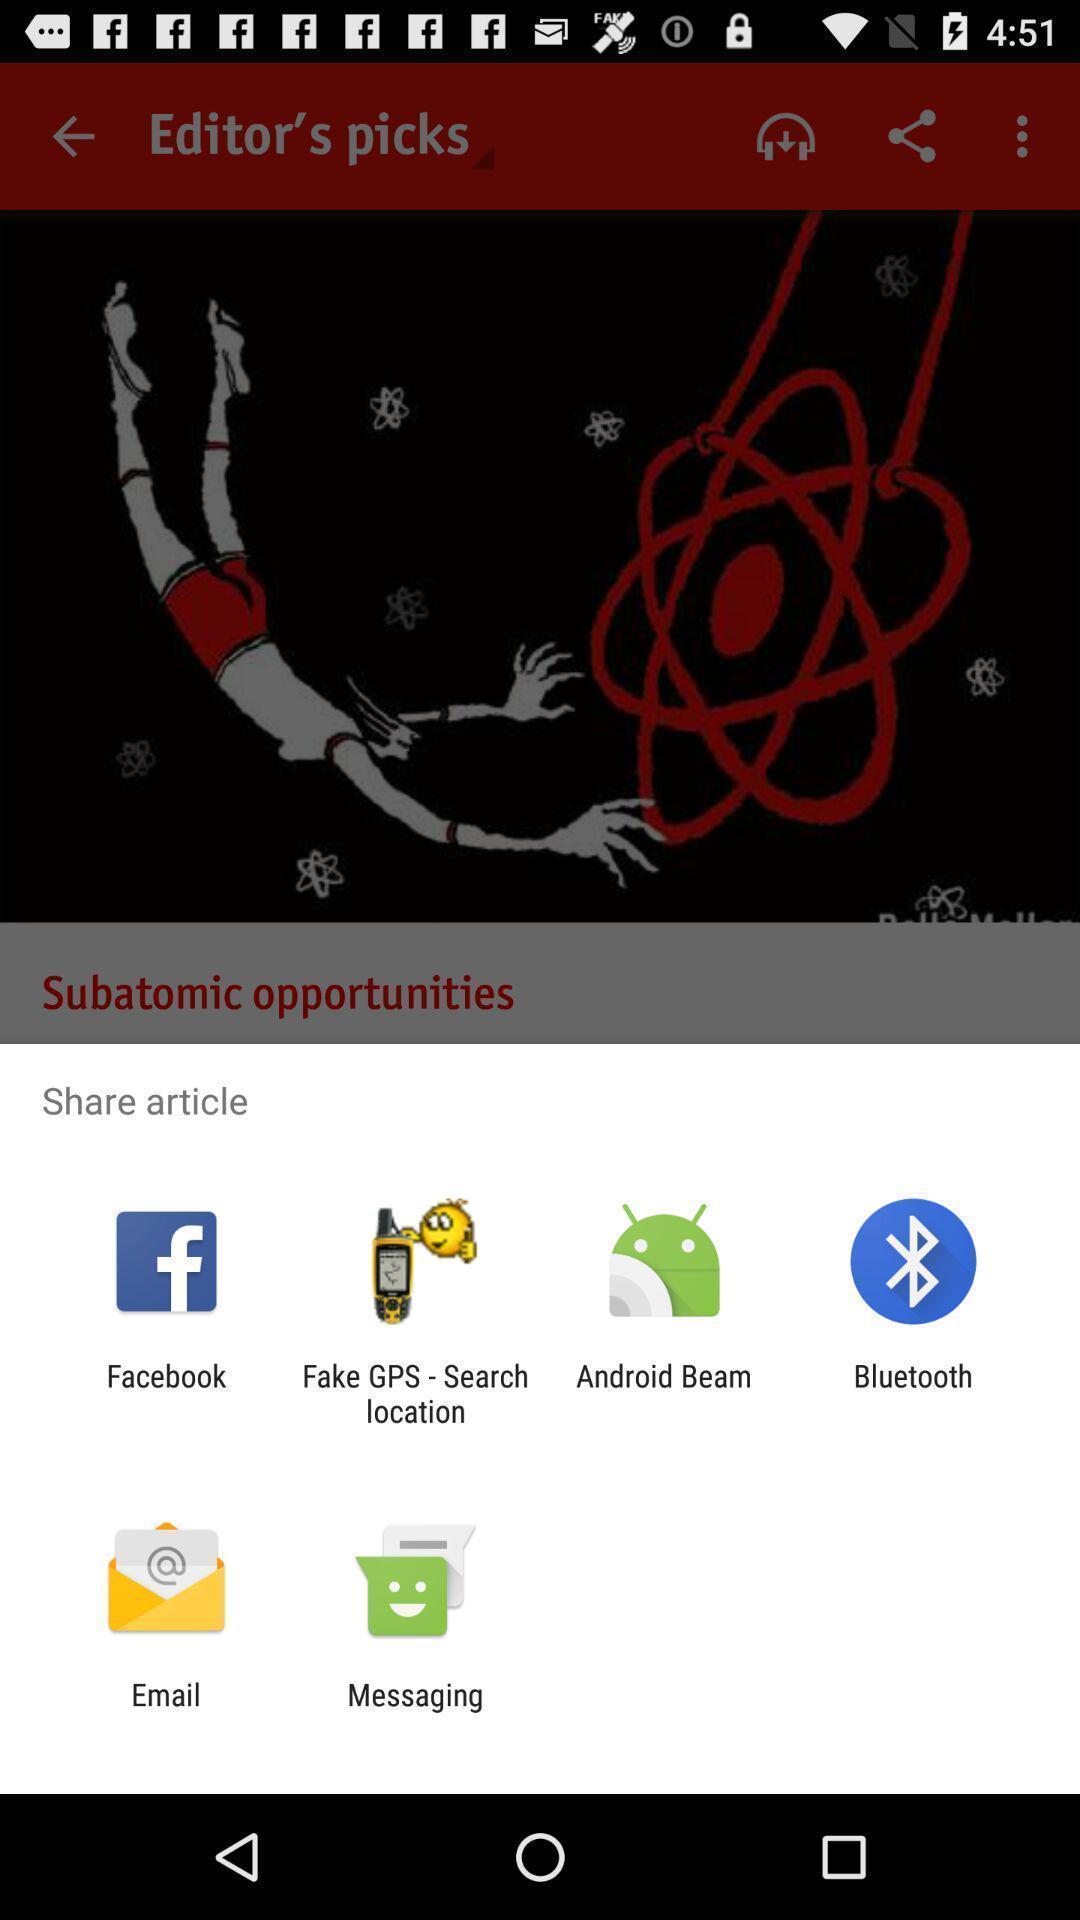Provide a detailed account of this screenshot. Pop up showing various apps. 